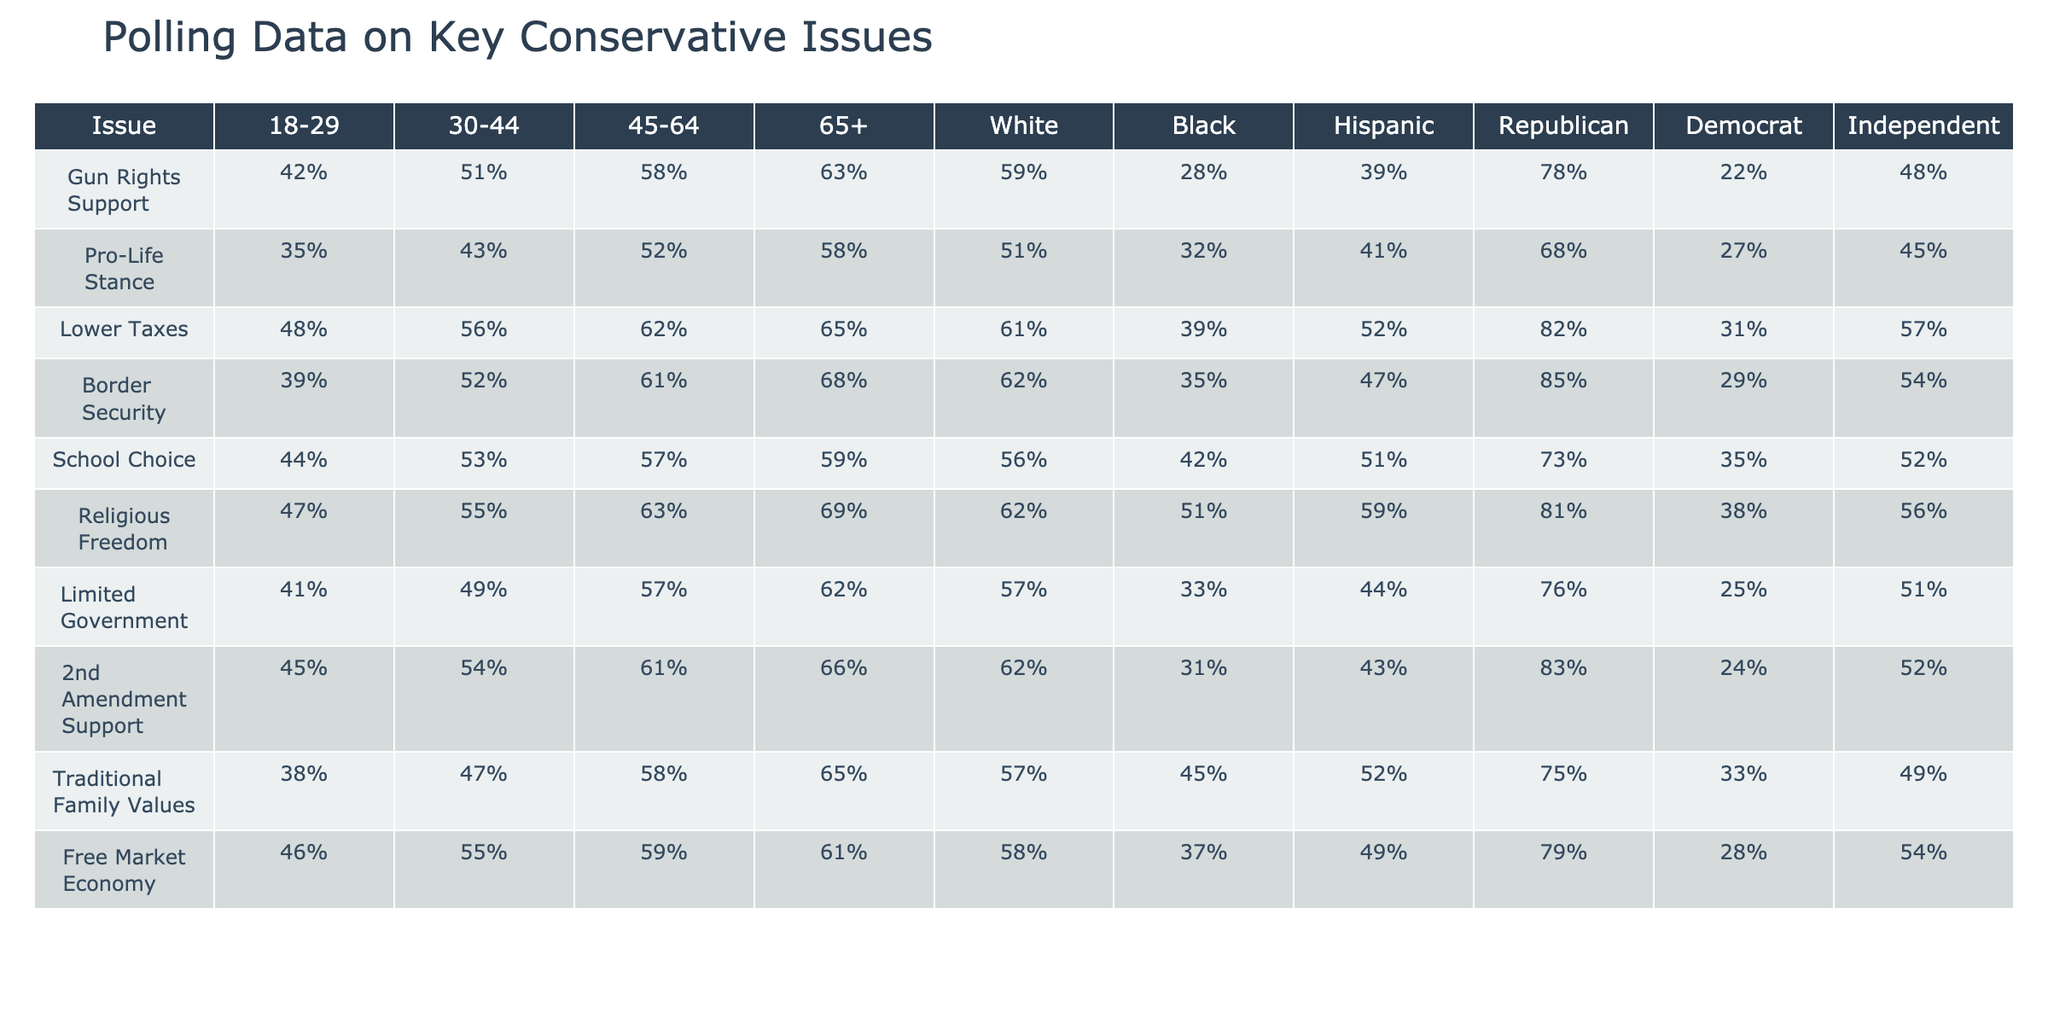What is the percentage of support for Gun Rights among those aged 65 and older? The table shows that support for Gun Rights among the 65+ demographic is 63%.
Answer: 63% Which demographic group shows the highest support for Lower Taxes? The table indicates that Republicans have the highest support for Lower Taxes at 82%.
Answer: 82% What is the difference in support for School Choice between Democrats and Republicans? Democrats show 35% support while Republicans show 73%, so the difference is 73% - 35% = 38%.
Answer: 38% Is the percentage of individuals aged 18-29 who support a Pro-Life stance higher than those aged 30-44? The table shows that support is 35% for ages 18-29 and 43% for ages 30-44, so it is false that the younger group has higher support.
Answer: No What is the average support for Border Security across all age groups? The percentages for the age groups are 39%, 52%, 61%, and 68%. The average is calculated as (39 + 52 + 61 + 68) / 4 = 55%.
Answer: 55% Among the Hispanic demographic, which issue has the highest level of support? Looking at the table, we see the levels of support for issues among Hispanics: Gun Rights (39%), Pro-Life (41%), Lower Taxes (52%), Border Security (47%), School Choice (51%), Religious Freedom (59%), Limited Government (44%), 2nd Amendment (43%), Traditional Family Values (52%), Free Market (49%). The highest is Religious Freedom at 59%.
Answer: 59% Which age group has the lowest support for Limited Government? The table shows that the 18-29 age group has the lowest support for Limited Government at 41%.
Answer: 41% What percentage of Black individuals support Traditional Family Values? The table indicates that support among Black individuals is 45%.
Answer: 45% Is there a significant gap in 2nd Amendment support between Independents and Republicans? Republicans support 83% while Independents support 52%, indicating a gap of 83% - 52% = 31%.
Answer: Yes What is the total percentage of support for Free Market Economy among all demographics listed? The table lists percentages: 46%, 55%, 59%, 61%, 58%, 37%, 49%, 79%, 28%, 54%. Adding these gives 46 + 55 + 59 + 61 + 58 + 37 + 49 + 79 + 28 + 54 = 492%.
Answer: 492% 